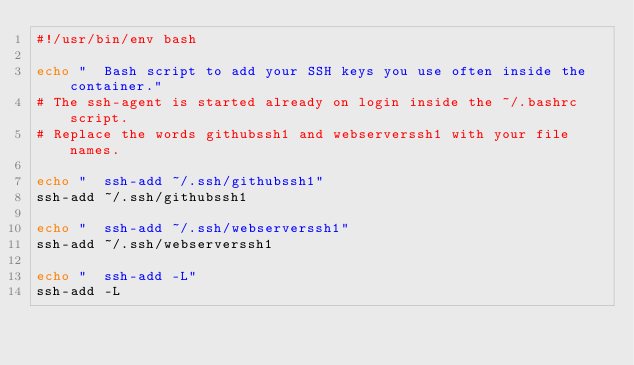<code> <loc_0><loc_0><loc_500><loc_500><_Bash_>#!/usr/bin/env bash

echo "  Bash script to add your SSH keys you use often inside the container."
# The ssh-agent is started already on login inside the ~/.bashrc script.
# Replace the words githubssh1 and webserverssh1 with your file names.

echo "  ssh-add ~/.ssh/githubssh1"
ssh-add ~/.ssh/githubssh1

echo "  ssh-add ~/.ssh/webserverssh1"
ssh-add ~/.ssh/webserverssh1

echo "  ssh-add -L"
ssh-add -L
</code> 